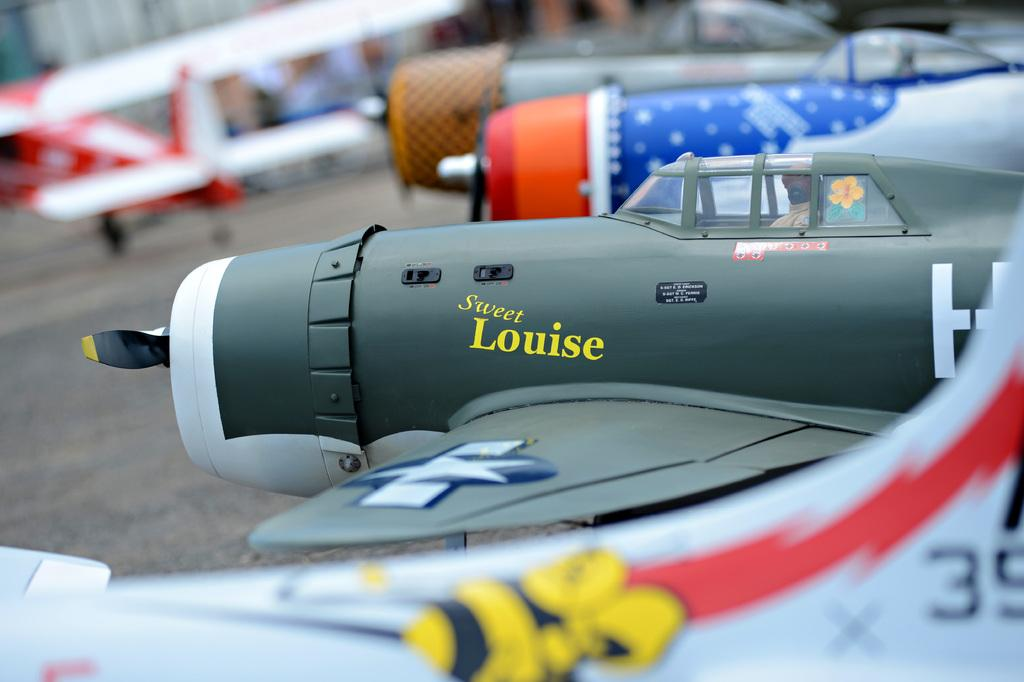<image>
Render a clear and concise summary of the photo. Sweet Louise and at least 3 other planes sit outside on the runway. 